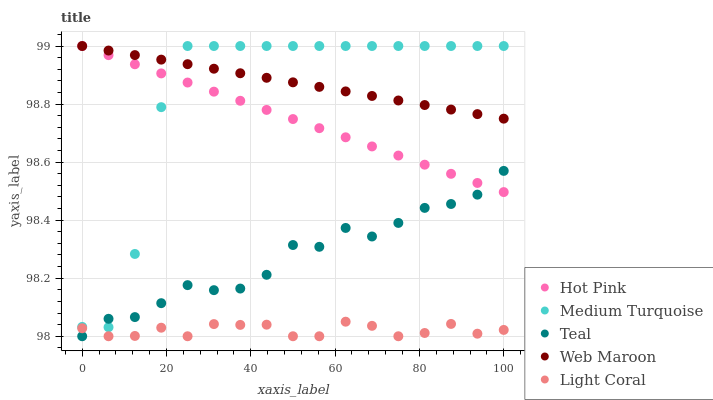Does Light Coral have the minimum area under the curve?
Answer yes or no. Yes. Does Web Maroon have the maximum area under the curve?
Answer yes or no. Yes. Does Hot Pink have the minimum area under the curve?
Answer yes or no. No. Does Hot Pink have the maximum area under the curve?
Answer yes or no. No. Is Hot Pink the smoothest?
Answer yes or no. Yes. Is Medium Turquoise the roughest?
Answer yes or no. Yes. Is Web Maroon the smoothest?
Answer yes or no. No. Is Web Maroon the roughest?
Answer yes or no. No. Does Light Coral have the lowest value?
Answer yes or no. Yes. Does Hot Pink have the lowest value?
Answer yes or no. No. Does Medium Turquoise have the highest value?
Answer yes or no. Yes. Does Teal have the highest value?
Answer yes or no. No. Is Light Coral less than Web Maroon?
Answer yes or no. Yes. Is Web Maroon greater than Light Coral?
Answer yes or no. Yes. Does Teal intersect Light Coral?
Answer yes or no. Yes. Is Teal less than Light Coral?
Answer yes or no. No. Is Teal greater than Light Coral?
Answer yes or no. No. Does Light Coral intersect Web Maroon?
Answer yes or no. No. 